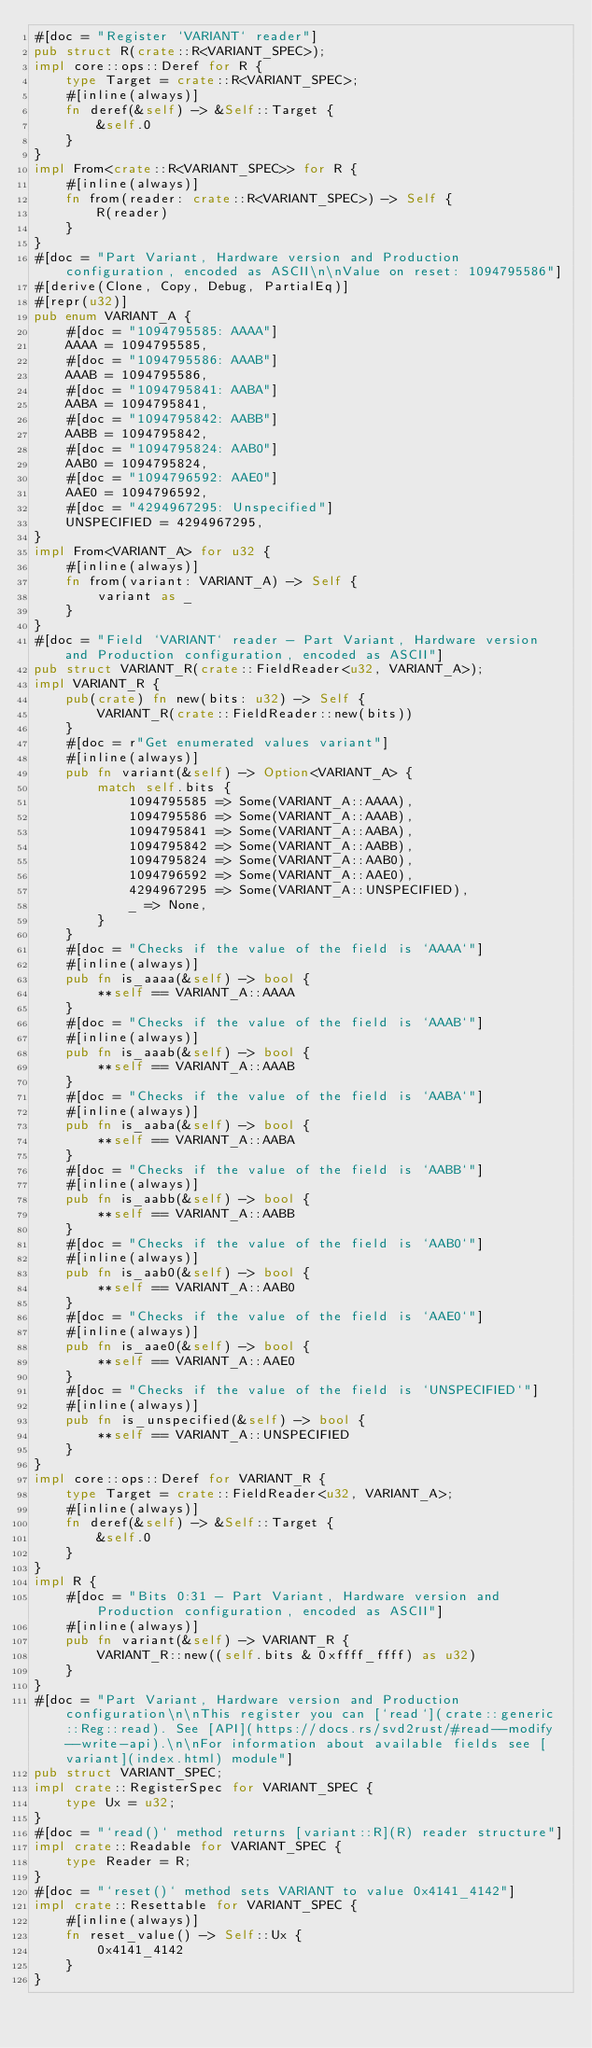<code> <loc_0><loc_0><loc_500><loc_500><_Rust_>#[doc = "Register `VARIANT` reader"]
pub struct R(crate::R<VARIANT_SPEC>);
impl core::ops::Deref for R {
    type Target = crate::R<VARIANT_SPEC>;
    #[inline(always)]
    fn deref(&self) -> &Self::Target {
        &self.0
    }
}
impl From<crate::R<VARIANT_SPEC>> for R {
    #[inline(always)]
    fn from(reader: crate::R<VARIANT_SPEC>) -> Self {
        R(reader)
    }
}
#[doc = "Part Variant, Hardware version and Production configuration, encoded as ASCII\n\nValue on reset: 1094795586"]
#[derive(Clone, Copy, Debug, PartialEq)]
#[repr(u32)]
pub enum VARIANT_A {
    #[doc = "1094795585: AAAA"]
    AAAA = 1094795585,
    #[doc = "1094795586: AAAB"]
    AAAB = 1094795586,
    #[doc = "1094795841: AABA"]
    AABA = 1094795841,
    #[doc = "1094795842: AABB"]
    AABB = 1094795842,
    #[doc = "1094795824: AAB0"]
    AAB0 = 1094795824,
    #[doc = "1094796592: AAE0"]
    AAE0 = 1094796592,
    #[doc = "4294967295: Unspecified"]
    UNSPECIFIED = 4294967295,
}
impl From<VARIANT_A> for u32 {
    #[inline(always)]
    fn from(variant: VARIANT_A) -> Self {
        variant as _
    }
}
#[doc = "Field `VARIANT` reader - Part Variant, Hardware version and Production configuration, encoded as ASCII"]
pub struct VARIANT_R(crate::FieldReader<u32, VARIANT_A>);
impl VARIANT_R {
    pub(crate) fn new(bits: u32) -> Self {
        VARIANT_R(crate::FieldReader::new(bits))
    }
    #[doc = r"Get enumerated values variant"]
    #[inline(always)]
    pub fn variant(&self) -> Option<VARIANT_A> {
        match self.bits {
            1094795585 => Some(VARIANT_A::AAAA),
            1094795586 => Some(VARIANT_A::AAAB),
            1094795841 => Some(VARIANT_A::AABA),
            1094795842 => Some(VARIANT_A::AABB),
            1094795824 => Some(VARIANT_A::AAB0),
            1094796592 => Some(VARIANT_A::AAE0),
            4294967295 => Some(VARIANT_A::UNSPECIFIED),
            _ => None,
        }
    }
    #[doc = "Checks if the value of the field is `AAAA`"]
    #[inline(always)]
    pub fn is_aaaa(&self) -> bool {
        **self == VARIANT_A::AAAA
    }
    #[doc = "Checks if the value of the field is `AAAB`"]
    #[inline(always)]
    pub fn is_aaab(&self) -> bool {
        **self == VARIANT_A::AAAB
    }
    #[doc = "Checks if the value of the field is `AABA`"]
    #[inline(always)]
    pub fn is_aaba(&self) -> bool {
        **self == VARIANT_A::AABA
    }
    #[doc = "Checks if the value of the field is `AABB`"]
    #[inline(always)]
    pub fn is_aabb(&self) -> bool {
        **self == VARIANT_A::AABB
    }
    #[doc = "Checks if the value of the field is `AAB0`"]
    #[inline(always)]
    pub fn is_aab0(&self) -> bool {
        **self == VARIANT_A::AAB0
    }
    #[doc = "Checks if the value of the field is `AAE0`"]
    #[inline(always)]
    pub fn is_aae0(&self) -> bool {
        **self == VARIANT_A::AAE0
    }
    #[doc = "Checks if the value of the field is `UNSPECIFIED`"]
    #[inline(always)]
    pub fn is_unspecified(&self) -> bool {
        **self == VARIANT_A::UNSPECIFIED
    }
}
impl core::ops::Deref for VARIANT_R {
    type Target = crate::FieldReader<u32, VARIANT_A>;
    #[inline(always)]
    fn deref(&self) -> &Self::Target {
        &self.0
    }
}
impl R {
    #[doc = "Bits 0:31 - Part Variant, Hardware version and Production configuration, encoded as ASCII"]
    #[inline(always)]
    pub fn variant(&self) -> VARIANT_R {
        VARIANT_R::new((self.bits & 0xffff_ffff) as u32)
    }
}
#[doc = "Part Variant, Hardware version and Production configuration\n\nThis register you can [`read`](crate::generic::Reg::read). See [API](https://docs.rs/svd2rust/#read--modify--write-api).\n\nFor information about available fields see [variant](index.html) module"]
pub struct VARIANT_SPEC;
impl crate::RegisterSpec for VARIANT_SPEC {
    type Ux = u32;
}
#[doc = "`read()` method returns [variant::R](R) reader structure"]
impl crate::Readable for VARIANT_SPEC {
    type Reader = R;
}
#[doc = "`reset()` method sets VARIANT to value 0x4141_4142"]
impl crate::Resettable for VARIANT_SPEC {
    #[inline(always)]
    fn reset_value() -> Self::Ux {
        0x4141_4142
    }
}
</code> 